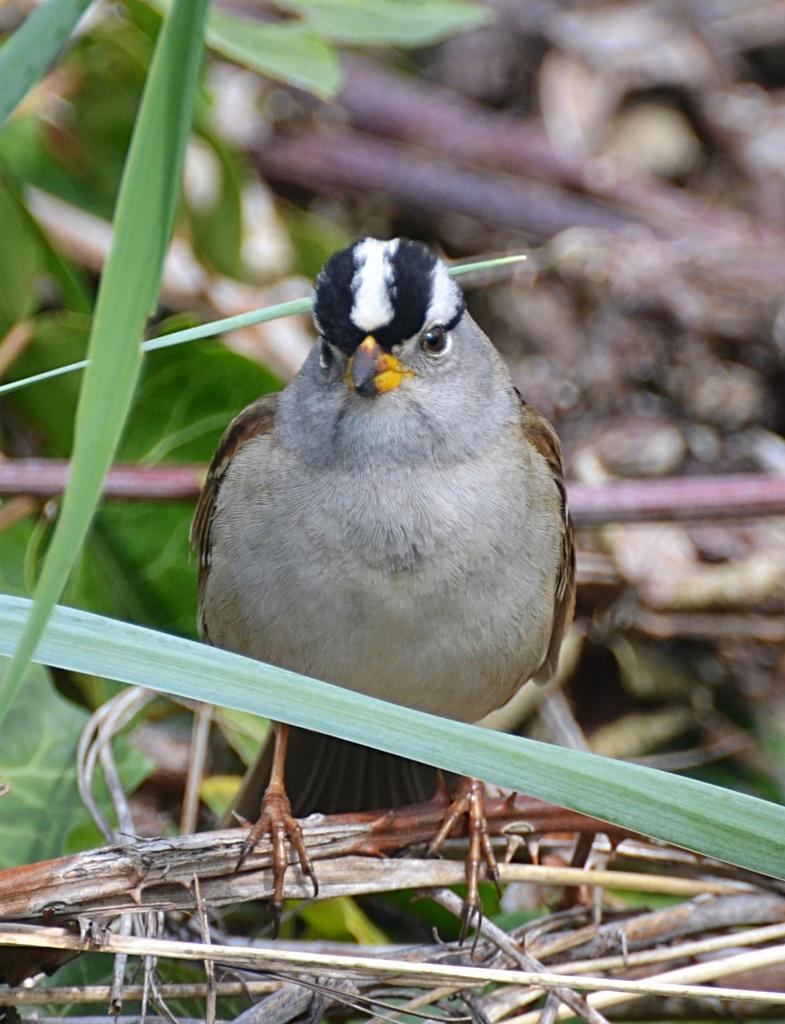Can you describe this image briefly? In this image we can see a bird on a branch, there we can see few branches and leaves. 